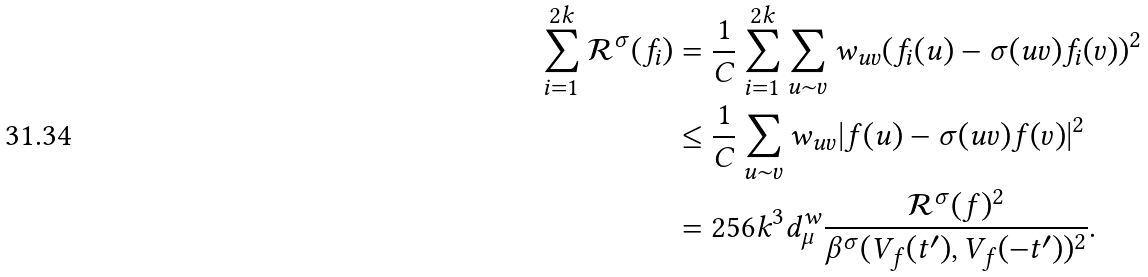Convert formula to latex. <formula><loc_0><loc_0><loc_500><loc_500>\sum _ { i = 1 } ^ { 2 k } \mathcal { R } ^ { \sigma } ( f _ { i } ) & = \frac { 1 } { C } \sum _ { i = 1 } ^ { 2 k } \sum _ { u \sim v } w _ { u v } ( f _ { i } ( u ) - \sigma ( u v ) f _ { i } ( v ) ) ^ { 2 } \\ & \leq \frac { 1 } { C } \sum _ { u \sim v } w _ { u v } | f ( u ) - \sigma ( u v ) f ( v ) | ^ { 2 } \\ & = 2 5 6 k ^ { 3 } d _ { \mu } ^ { w } \frac { \mathcal { R } ^ { \sigma } ( f ) ^ { 2 } } { \beta ^ { \sigma } ( V _ { f } ( t ^ { \prime } ) , V _ { f } ( - t ^ { \prime } ) ) ^ { 2 } } .</formula> 